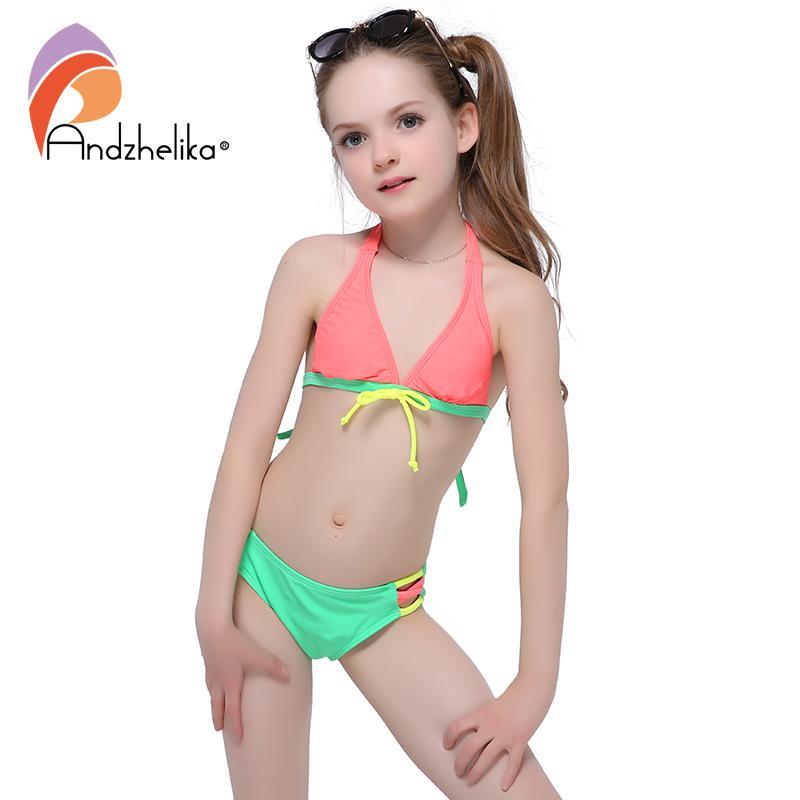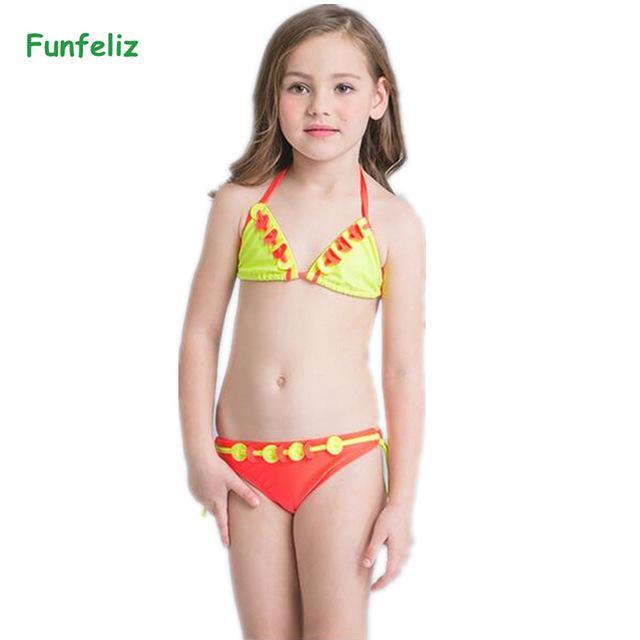The first image is the image on the left, the second image is the image on the right. Analyze the images presented: Is the assertion "At least one of the bikini models pictured is a child." valid? Answer yes or no. Yes. 